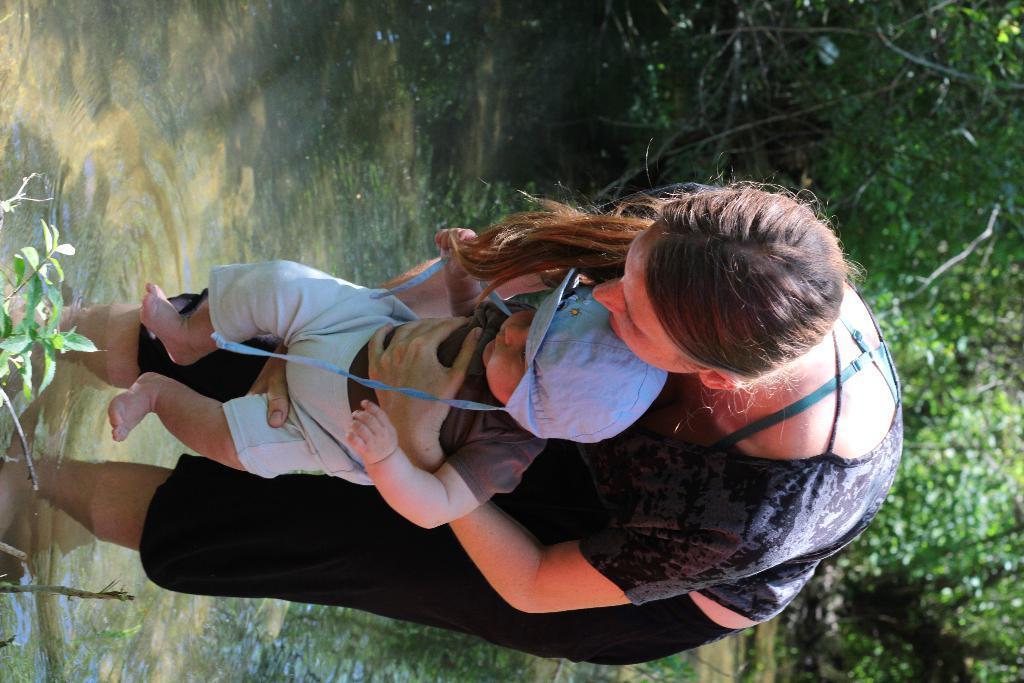Describe this image in one or two sentences. In this image, I can see a woman standing in the water and carrying a baby. On the left side of the image, I can see the leaves. On the right side of the image, there are trees. 